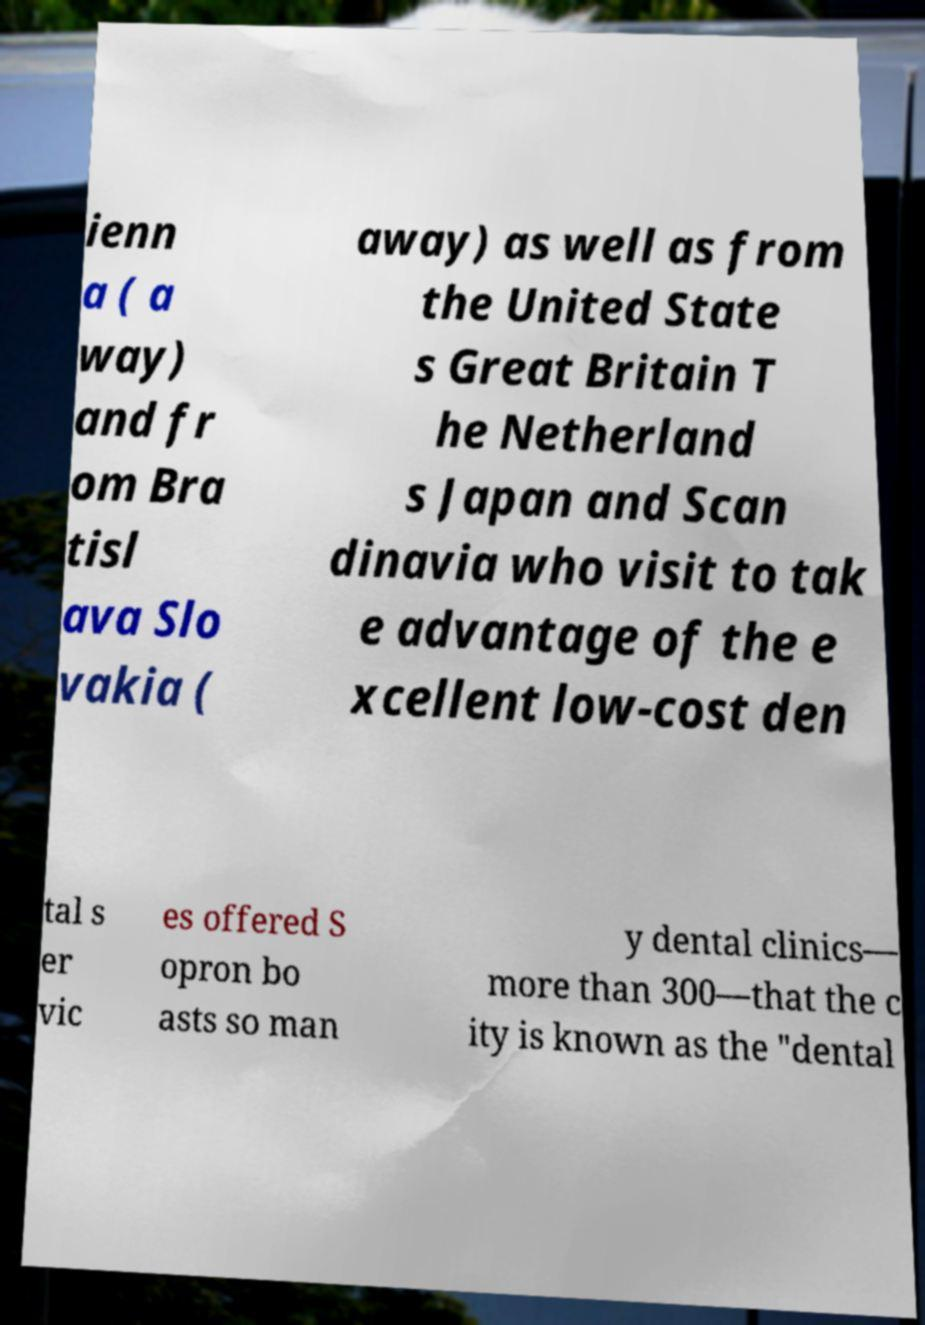Can you accurately transcribe the text from the provided image for me? ienn a ( a way) and fr om Bra tisl ava Slo vakia ( away) as well as from the United State s Great Britain T he Netherland s Japan and Scan dinavia who visit to tak e advantage of the e xcellent low-cost den tal s er vic es offered S opron bo asts so man y dental clinics— more than 300—that the c ity is known as the "dental 